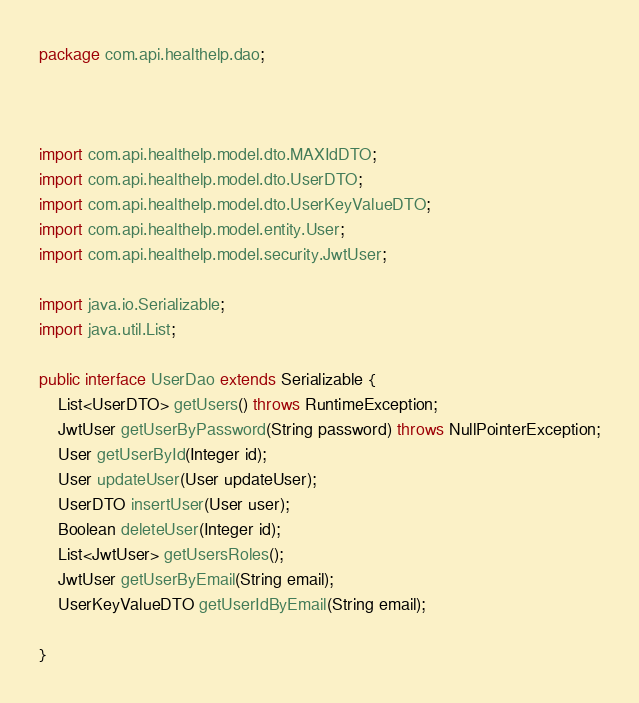<code> <loc_0><loc_0><loc_500><loc_500><_Java_>package com.api.healthelp.dao;



import com.api.healthelp.model.dto.MAXIdDTO;
import com.api.healthelp.model.dto.UserDTO;
import com.api.healthelp.model.dto.UserKeyValueDTO;
import com.api.healthelp.model.entity.User;
import com.api.healthelp.model.security.JwtUser;

import java.io.Serializable;
import java.util.List;

public interface UserDao extends Serializable {
    List<UserDTO> getUsers() throws RuntimeException;
    JwtUser getUserByPassword(String password) throws NullPointerException;
    User getUserById(Integer id);
    User updateUser(User updateUser);
    UserDTO insertUser(User user);
    Boolean deleteUser(Integer id);
    List<JwtUser> getUsersRoles();
    JwtUser getUserByEmail(String email);
    UserKeyValueDTO getUserIdByEmail(String email);

}

</code> 